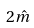<formula> <loc_0><loc_0><loc_500><loc_500>2 \hat { m }</formula> 